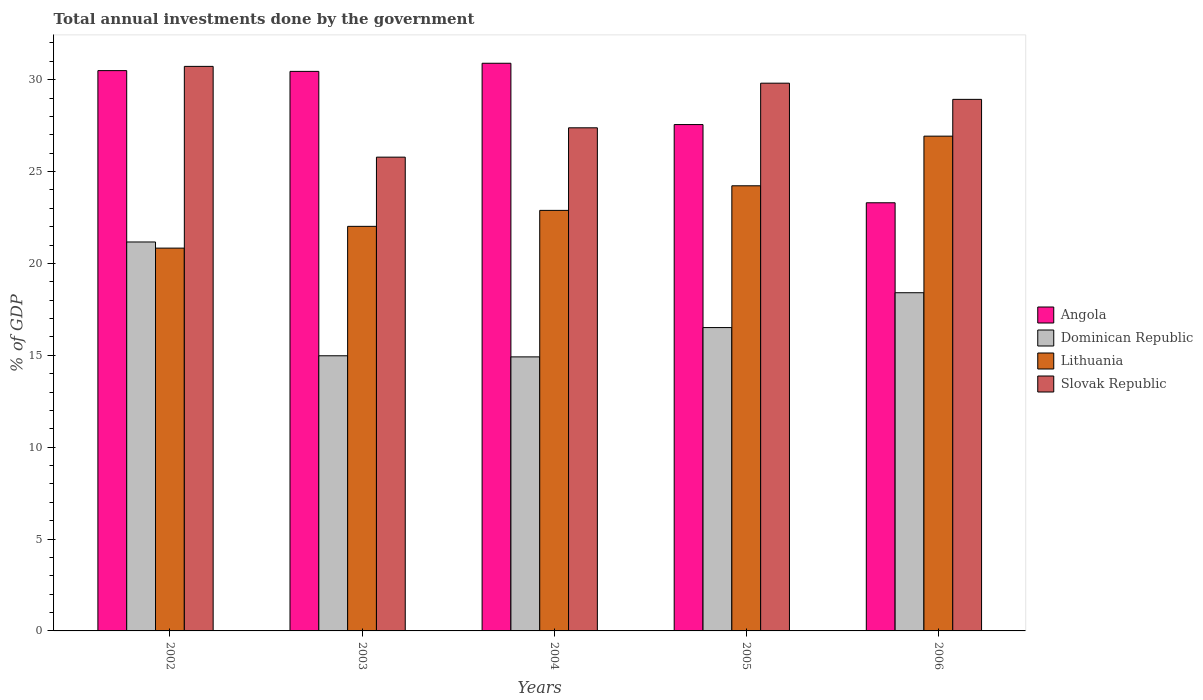How many groups of bars are there?
Give a very brief answer. 5. Are the number of bars on each tick of the X-axis equal?
Provide a succinct answer. Yes. In how many cases, is the number of bars for a given year not equal to the number of legend labels?
Offer a terse response. 0. What is the total annual investments done by the government in Lithuania in 2005?
Keep it short and to the point. 24.22. Across all years, what is the maximum total annual investments done by the government in Dominican Republic?
Keep it short and to the point. 21.17. Across all years, what is the minimum total annual investments done by the government in Dominican Republic?
Give a very brief answer. 14.91. In which year was the total annual investments done by the government in Dominican Republic maximum?
Provide a succinct answer. 2002. In which year was the total annual investments done by the government in Angola minimum?
Your answer should be very brief. 2006. What is the total total annual investments done by the government in Slovak Republic in the graph?
Offer a terse response. 142.63. What is the difference between the total annual investments done by the government in Lithuania in 2002 and that in 2003?
Keep it short and to the point. -1.19. What is the difference between the total annual investments done by the government in Dominican Republic in 2006 and the total annual investments done by the government in Angola in 2004?
Offer a very short reply. -12.49. What is the average total annual investments done by the government in Angola per year?
Your answer should be compact. 28.54. In the year 2002, what is the difference between the total annual investments done by the government in Dominican Republic and total annual investments done by the government in Angola?
Ensure brevity in your answer.  -9.33. In how many years, is the total annual investments done by the government in Angola greater than 23 %?
Your answer should be very brief. 5. What is the ratio of the total annual investments done by the government in Slovak Republic in 2002 to that in 2004?
Your answer should be compact. 1.12. Is the total annual investments done by the government in Slovak Republic in 2004 less than that in 2006?
Keep it short and to the point. Yes. What is the difference between the highest and the second highest total annual investments done by the government in Angola?
Your answer should be compact. 0.4. What is the difference between the highest and the lowest total annual investments done by the government in Dominican Republic?
Provide a succinct answer. 6.25. In how many years, is the total annual investments done by the government in Lithuania greater than the average total annual investments done by the government in Lithuania taken over all years?
Provide a short and direct response. 2. Is the sum of the total annual investments done by the government in Dominican Republic in 2003 and 2005 greater than the maximum total annual investments done by the government in Lithuania across all years?
Your answer should be very brief. Yes. Is it the case that in every year, the sum of the total annual investments done by the government in Angola and total annual investments done by the government in Slovak Republic is greater than the sum of total annual investments done by the government in Lithuania and total annual investments done by the government in Dominican Republic?
Your answer should be very brief. No. What does the 1st bar from the left in 2005 represents?
Give a very brief answer. Angola. What does the 2nd bar from the right in 2003 represents?
Ensure brevity in your answer.  Lithuania. Is it the case that in every year, the sum of the total annual investments done by the government in Dominican Republic and total annual investments done by the government in Angola is greater than the total annual investments done by the government in Slovak Republic?
Give a very brief answer. Yes. How many bars are there?
Provide a succinct answer. 20. Where does the legend appear in the graph?
Your answer should be compact. Center right. What is the title of the graph?
Your answer should be compact. Total annual investments done by the government. What is the label or title of the X-axis?
Offer a very short reply. Years. What is the label or title of the Y-axis?
Offer a very short reply. % of GDP. What is the % of GDP of Angola in 2002?
Provide a short and direct response. 30.49. What is the % of GDP of Dominican Republic in 2002?
Offer a very short reply. 21.17. What is the % of GDP of Lithuania in 2002?
Give a very brief answer. 20.83. What is the % of GDP in Slovak Republic in 2002?
Keep it short and to the point. 30.72. What is the % of GDP of Angola in 2003?
Your response must be concise. 30.45. What is the % of GDP in Dominican Republic in 2003?
Offer a terse response. 14.97. What is the % of GDP in Lithuania in 2003?
Ensure brevity in your answer.  22.02. What is the % of GDP of Slovak Republic in 2003?
Make the answer very short. 25.78. What is the % of GDP in Angola in 2004?
Offer a very short reply. 30.89. What is the % of GDP in Dominican Republic in 2004?
Your answer should be compact. 14.91. What is the % of GDP in Lithuania in 2004?
Offer a terse response. 22.89. What is the % of GDP of Slovak Republic in 2004?
Your answer should be very brief. 27.38. What is the % of GDP of Angola in 2005?
Give a very brief answer. 27.56. What is the % of GDP of Dominican Republic in 2005?
Provide a short and direct response. 16.51. What is the % of GDP of Lithuania in 2005?
Your answer should be compact. 24.22. What is the % of GDP of Slovak Republic in 2005?
Provide a succinct answer. 29.81. What is the % of GDP in Angola in 2006?
Provide a succinct answer. 23.3. What is the % of GDP in Dominican Republic in 2006?
Your answer should be very brief. 18.41. What is the % of GDP of Lithuania in 2006?
Offer a terse response. 26.93. What is the % of GDP of Slovak Republic in 2006?
Keep it short and to the point. 28.93. Across all years, what is the maximum % of GDP in Angola?
Your answer should be compact. 30.89. Across all years, what is the maximum % of GDP in Dominican Republic?
Provide a short and direct response. 21.17. Across all years, what is the maximum % of GDP in Lithuania?
Your answer should be very brief. 26.93. Across all years, what is the maximum % of GDP in Slovak Republic?
Offer a terse response. 30.72. Across all years, what is the minimum % of GDP in Angola?
Offer a terse response. 23.3. Across all years, what is the minimum % of GDP of Dominican Republic?
Keep it short and to the point. 14.91. Across all years, what is the minimum % of GDP of Lithuania?
Ensure brevity in your answer.  20.83. Across all years, what is the minimum % of GDP in Slovak Republic?
Ensure brevity in your answer.  25.78. What is the total % of GDP of Angola in the graph?
Provide a short and direct response. 142.7. What is the total % of GDP of Dominican Republic in the graph?
Keep it short and to the point. 85.97. What is the total % of GDP in Lithuania in the graph?
Make the answer very short. 116.89. What is the total % of GDP of Slovak Republic in the graph?
Give a very brief answer. 142.63. What is the difference between the % of GDP of Angola in 2002 and that in 2003?
Offer a very short reply. 0.04. What is the difference between the % of GDP of Dominican Republic in 2002 and that in 2003?
Give a very brief answer. 6.19. What is the difference between the % of GDP in Lithuania in 2002 and that in 2003?
Offer a very short reply. -1.19. What is the difference between the % of GDP in Slovak Republic in 2002 and that in 2003?
Offer a very short reply. 4.94. What is the difference between the % of GDP in Angola in 2002 and that in 2004?
Make the answer very short. -0.4. What is the difference between the % of GDP of Dominican Republic in 2002 and that in 2004?
Offer a very short reply. 6.25. What is the difference between the % of GDP in Lithuania in 2002 and that in 2004?
Your response must be concise. -2.05. What is the difference between the % of GDP of Slovak Republic in 2002 and that in 2004?
Keep it short and to the point. 3.34. What is the difference between the % of GDP of Angola in 2002 and that in 2005?
Offer a terse response. 2.94. What is the difference between the % of GDP in Dominican Republic in 2002 and that in 2005?
Provide a short and direct response. 4.66. What is the difference between the % of GDP in Lithuania in 2002 and that in 2005?
Give a very brief answer. -3.39. What is the difference between the % of GDP of Slovak Republic in 2002 and that in 2005?
Keep it short and to the point. 0.91. What is the difference between the % of GDP of Angola in 2002 and that in 2006?
Make the answer very short. 7.19. What is the difference between the % of GDP in Dominican Republic in 2002 and that in 2006?
Your answer should be compact. 2.76. What is the difference between the % of GDP of Lithuania in 2002 and that in 2006?
Offer a very short reply. -6.09. What is the difference between the % of GDP in Slovak Republic in 2002 and that in 2006?
Your answer should be very brief. 1.79. What is the difference between the % of GDP in Angola in 2003 and that in 2004?
Provide a short and direct response. -0.44. What is the difference between the % of GDP of Dominican Republic in 2003 and that in 2004?
Keep it short and to the point. 0.06. What is the difference between the % of GDP in Lithuania in 2003 and that in 2004?
Give a very brief answer. -0.87. What is the difference between the % of GDP in Slovak Republic in 2003 and that in 2004?
Make the answer very short. -1.6. What is the difference between the % of GDP in Angola in 2003 and that in 2005?
Provide a short and direct response. 2.89. What is the difference between the % of GDP of Dominican Republic in 2003 and that in 2005?
Make the answer very short. -1.54. What is the difference between the % of GDP in Lithuania in 2003 and that in 2005?
Your answer should be very brief. -2.21. What is the difference between the % of GDP in Slovak Republic in 2003 and that in 2005?
Provide a short and direct response. -4.03. What is the difference between the % of GDP of Angola in 2003 and that in 2006?
Your response must be concise. 7.15. What is the difference between the % of GDP in Dominican Republic in 2003 and that in 2006?
Keep it short and to the point. -3.43. What is the difference between the % of GDP in Lithuania in 2003 and that in 2006?
Make the answer very short. -4.91. What is the difference between the % of GDP in Slovak Republic in 2003 and that in 2006?
Provide a succinct answer. -3.14. What is the difference between the % of GDP of Angola in 2004 and that in 2005?
Provide a short and direct response. 3.34. What is the difference between the % of GDP in Dominican Republic in 2004 and that in 2005?
Give a very brief answer. -1.6. What is the difference between the % of GDP in Lithuania in 2004 and that in 2005?
Keep it short and to the point. -1.34. What is the difference between the % of GDP in Slovak Republic in 2004 and that in 2005?
Provide a succinct answer. -2.43. What is the difference between the % of GDP in Angola in 2004 and that in 2006?
Your answer should be compact. 7.59. What is the difference between the % of GDP of Dominican Republic in 2004 and that in 2006?
Your answer should be very brief. -3.49. What is the difference between the % of GDP in Lithuania in 2004 and that in 2006?
Keep it short and to the point. -4.04. What is the difference between the % of GDP of Slovak Republic in 2004 and that in 2006?
Provide a short and direct response. -1.55. What is the difference between the % of GDP of Angola in 2005 and that in 2006?
Keep it short and to the point. 4.26. What is the difference between the % of GDP in Dominican Republic in 2005 and that in 2006?
Offer a terse response. -1.9. What is the difference between the % of GDP in Lithuania in 2005 and that in 2006?
Your answer should be compact. -2.7. What is the difference between the % of GDP of Slovak Republic in 2005 and that in 2006?
Offer a very short reply. 0.88. What is the difference between the % of GDP of Angola in 2002 and the % of GDP of Dominican Republic in 2003?
Offer a terse response. 15.52. What is the difference between the % of GDP of Angola in 2002 and the % of GDP of Lithuania in 2003?
Keep it short and to the point. 8.47. What is the difference between the % of GDP in Angola in 2002 and the % of GDP in Slovak Republic in 2003?
Your answer should be compact. 4.71. What is the difference between the % of GDP of Dominican Republic in 2002 and the % of GDP of Lithuania in 2003?
Your response must be concise. -0.85. What is the difference between the % of GDP in Dominican Republic in 2002 and the % of GDP in Slovak Republic in 2003?
Provide a succinct answer. -4.62. What is the difference between the % of GDP in Lithuania in 2002 and the % of GDP in Slovak Republic in 2003?
Keep it short and to the point. -4.95. What is the difference between the % of GDP of Angola in 2002 and the % of GDP of Dominican Republic in 2004?
Your response must be concise. 15.58. What is the difference between the % of GDP of Angola in 2002 and the % of GDP of Lithuania in 2004?
Your answer should be compact. 7.61. What is the difference between the % of GDP in Angola in 2002 and the % of GDP in Slovak Republic in 2004?
Your response must be concise. 3.11. What is the difference between the % of GDP of Dominican Republic in 2002 and the % of GDP of Lithuania in 2004?
Give a very brief answer. -1.72. What is the difference between the % of GDP of Dominican Republic in 2002 and the % of GDP of Slovak Republic in 2004?
Ensure brevity in your answer.  -6.21. What is the difference between the % of GDP in Lithuania in 2002 and the % of GDP in Slovak Republic in 2004?
Provide a succinct answer. -6.55. What is the difference between the % of GDP of Angola in 2002 and the % of GDP of Dominican Republic in 2005?
Make the answer very short. 13.98. What is the difference between the % of GDP of Angola in 2002 and the % of GDP of Lithuania in 2005?
Your answer should be compact. 6.27. What is the difference between the % of GDP in Angola in 2002 and the % of GDP in Slovak Republic in 2005?
Give a very brief answer. 0.68. What is the difference between the % of GDP in Dominican Republic in 2002 and the % of GDP in Lithuania in 2005?
Provide a short and direct response. -3.06. What is the difference between the % of GDP of Dominican Republic in 2002 and the % of GDP of Slovak Republic in 2005?
Give a very brief answer. -8.64. What is the difference between the % of GDP of Lithuania in 2002 and the % of GDP of Slovak Republic in 2005?
Offer a terse response. -8.98. What is the difference between the % of GDP in Angola in 2002 and the % of GDP in Dominican Republic in 2006?
Offer a very short reply. 12.09. What is the difference between the % of GDP in Angola in 2002 and the % of GDP in Lithuania in 2006?
Your response must be concise. 3.57. What is the difference between the % of GDP in Angola in 2002 and the % of GDP in Slovak Republic in 2006?
Ensure brevity in your answer.  1.56. What is the difference between the % of GDP in Dominican Republic in 2002 and the % of GDP in Lithuania in 2006?
Ensure brevity in your answer.  -5.76. What is the difference between the % of GDP of Dominican Republic in 2002 and the % of GDP of Slovak Republic in 2006?
Make the answer very short. -7.76. What is the difference between the % of GDP of Lithuania in 2002 and the % of GDP of Slovak Republic in 2006?
Ensure brevity in your answer.  -8.1. What is the difference between the % of GDP in Angola in 2003 and the % of GDP in Dominican Republic in 2004?
Offer a very short reply. 15.54. What is the difference between the % of GDP of Angola in 2003 and the % of GDP of Lithuania in 2004?
Keep it short and to the point. 7.56. What is the difference between the % of GDP in Angola in 2003 and the % of GDP in Slovak Republic in 2004?
Keep it short and to the point. 3.07. What is the difference between the % of GDP of Dominican Republic in 2003 and the % of GDP of Lithuania in 2004?
Ensure brevity in your answer.  -7.91. What is the difference between the % of GDP of Dominican Republic in 2003 and the % of GDP of Slovak Republic in 2004?
Keep it short and to the point. -12.41. What is the difference between the % of GDP in Lithuania in 2003 and the % of GDP in Slovak Republic in 2004?
Provide a succinct answer. -5.36. What is the difference between the % of GDP in Angola in 2003 and the % of GDP in Dominican Republic in 2005?
Keep it short and to the point. 13.94. What is the difference between the % of GDP in Angola in 2003 and the % of GDP in Lithuania in 2005?
Offer a very short reply. 6.23. What is the difference between the % of GDP of Angola in 2003 and the % of GDP of Slovak Republic in 2005?
Offer a terse response. 0.64. What is the difference between the % of GDP in Dominican Republic in 2003 and the % of GDP in Lithuania in 2005?
Provide a succinct answer. -9.25. What is the difference between the % of GDP in Dominican Republic in 2003 and the % of GDP in Slovak Republic in 2005?
Provide a short and direct response. -14.84. What is the difference between the % of GDP in Lithuania in 2003 and the % of GDP in Slovak Republic in 2005?
Offer a terse response. -7.79. What is the difference between the % of GDP in Angola in 2003 and the % of GDP in Dominican Republic in 2006?
Provide a succinct answer. 12.05. What is the difference between the % of GDP of Angola in 2003 and the % of GDP of Lithuania in 2006?
Provide a short and direct response. 3.52. What is the difference between the % of GDP of Angola in 2003 and the % of GDP of Slovak Republic in 2006?
Ensure brevity in your answer.  1.52. What is the difference between the % of GDP of Dominican Republic in 2003 and the % of GDP of Lithuania in 2006?
Your response must be concise. -11.95. What is the difference between the % of GDP in Dominican Republic in 2003 and the % of GDP in Slovak Republic in 2006?
Offer a very short reply. -13.95. What is the difference between the % of GDP in Lithuania in 2003 and the % of GDP in Slovak Republic in 2006?
Your answer should be very brief. -6.91. What is the difference between the % of GDP in Angola in 2004 and the % of GDP in Dominican Republic in 2005?
Your response must be concise. 14.38. What is the difference between the % of GDP in Angola in 2004 and the % of GDP in Lithuania in 2005?
Ensure brevity in your answer.  6.67. What is the difference between the % of GDP in Angola in 2004 and the % of GDP in Slovak Republic in 2005?
Provide a succinct answer. 1.08. What is the difference between the % of GDP in Dominican Republic in 2004 and the % of GDP in Lithuania in 2005?
Offer a very short reply. -9.31. What is the difference between the % of GDP in Dominican Republic in 2004 and the % of GDP in Slovak Republic in 2005?
Offer a terse response. -14.9. What is the difference between the % of GDP of Lithuania in 2004 and the % of GDP of Slovak Republic in 2005?
Provide a short and direct response. -6.92. What is the difference between the % of GDP of Angola in 2004 and the % of GDP of Dominican Republic in 2006?
Your response must be concise. 12.49. What is the difference between the % of GDP of Angola in 2004 and the % of GDP of Lithuania in 2006?
Make the answer very short. 3.97. What is the difference between the % of GDP of Angola in 2004 and the % of GDP of Slovak Republic in 2006?
Provide a short and direct response. 1.96. What is the difference between the % of GDP in Dominican Republic in 2004 and the % of GDP in Lithuania in 2006?
Offer a very short reply. -12.01. What is the difference between the % of GDP of Dominican Republic in 2004 and the % of GDP of Slovak Republic in 2006?
Make the answer very short. -14.02. What is the difference between the % of GDP in Lithuania in 2004 and the % of GDP in Slovak Republic in 2006?
Your answer should be very brief. -6.04. What is the difference between the % of GDP in Angola in 2005 and the % of GDP in Dominican Republic in 2006?
Give a very brief answer. 9.15. What is the difference between the % of GDP in Angola in 2005 and the % of GDP in Lithuania in 2006?
Make the answer very short. 0.63. What is the difference between the % of GDP in Angola in 2005 and the % of GDP in Slovak Republic in 2006?
Give a very brief answer. -1.37. What is the difference between the % of GDP of Dominican Republic in 2005 and the % of GDP of Lithuania in 2006?
Give a very brief answer. -10.42. What is the difference between the % of GDP in Dominican Republic in 2005 and the % of GDP in Slovak Republic in 2006?
Offer a very short reply. -12.42. What is the difference between the % of GDP in Lithuania in 2005 and the % of GDP in Slovak Republic in 2006?
Offer a very short reply. -4.7. What is the average % of GDP of Angola per year?
Provide a succinct answer. 28.54. What is the average % of GDP of Dominican Republic per year?
Give a very brief answer. 17.19. What is the average % of GDP in Lithuania per year?
Your answer should be very brief. 23.38. What is the average % of GDP of Slovak Republic per year?
Provide a succinct answer. 28.53. In the year 2002, what is the difference between the % of GDP of Angola and % of GDP of Dominican Republic?
Give a very brief answer. 9.33. In the year 2002, what is the difference between the % of GDP in Angola and % of GDP in Lithuania?
Provide a short and direct response. 9.66. In the year 2002, what is the difference between the % of GDP in Angola and % of GDP in Slovak Republic?
Provide a short and direct response. -0.23. In the year 2002, what is the difference between the % of GDP in Dominican Republic and % of GDP in Lithuania?
Keep it short and to the point. 0.33. In the year 2002, what is the difference between the % of GDP of Dominican Republic and % of GDP of Slovak Republic?
Make the answer very short. -9.56. In the year 2002, what is the difference between the % of GDP in Lithuania and % of GDP in Slovak Republic?
Offer a terse response. -9.89. In the year 2003, what is the difference between the % of GDP in Angola and % of GDP in Dominican Republic?
Give a very brief answer. 15.48. In the year 2003, what is the difference between the % of GDP of Angola and % of GDP of Lithuania?
Offer a very short reply. 8.43. In the year 2003, what is the difference between the % of GDP of Angola and % of GDP of Slovak Republic?
Your answer should be very brief. 4.67. In the year 2003, what is the difference between the % of GDP in Dominican Republic and % of GDP in Lithuania?
Your answer should be compact. -7.04. In the year 2003, what is the difference between the % of GDP of Dominican Republic and % of GDP of Slovak Republic?
Give a very brief answer. -10.81. In the year 2003, what is the difference between the % of GDP of Lithuania and % of GDP of Slovak Republic?
Ensure brevity in your answer.  -3.77. In the year 2004, what is the difference between the % of GDP of Angola and % of GDP of Dominican Republic?
Make the answer very short. 15.98. In the year 2004, what is the difference between the % of GDP in Angola and % of GDP in Lithuania?
Your answer should be very brief. 8.01. In the year 2004, what is the difference between the % of GDP in Angola and % of GDP in Slovak Republic?
Provide a succinct answer. 3.51. In the year 2004, what is the difference between the % of GDP of Dominican Republic and % of GDP of Lithuania?
Your answer should be very brief. -7.97. In the year 2004, what is the difference between the % of GDP of Dominican Republic and % of GDP of Slovak Republic?
Provide a short and direct response. -12.47. In the year 2004, what is the difference between the % of GDP of Lithuania and % of GDP of Slovak Republic?
Offer a terse response. -4.49. In the year 2005, what is the difference between the % of GDP in Angola and % of GDP in Dominican Republic?
Offer a terse response. 11.05. In the year 2005, what is the difference between the % of GDP of Angola and % of GDP of Lithuania?
Provide a short and direct response. 3.33. In the year 2005, what is the difference between the % of GDP in Angola and % of GDP in Slovak Republic?
Provide a succinct answer. -2.25. In the year 2005, what is the difference between the % of GDP in Dominican Republic and % of GDP in Lithuania?
Provide a short and direct response. -7.72. In the year 2005, what is the difference between the % of GDP of Dominican Republic and % of GDP of Slovak Republic?
Your answer should be compact. -13.3. In the year 2005, what is the difference between the % of GDP in Lithuania and % of GDP in Slovak Republic?
Ensure brevity in your answer.  -5.58. In the year 2006, what is the difference between the % of GDP of Angola and % of GDP of Dominican Republic?
Offer a very short reply. 4.9. In the year 2006, what is the difference between the % of GDP in Angola and % of GDP in Lithuania?
Provide a succinct answer. -3.63. In the year 2006, what is the difference between the % of GDP in Angola and % of GDP in Slovak Republic?
Provide a succinct answer. -5.63. In the year 2006, what is the difference between the % of GDP of Dominican Republic and % of GDP of Lithuania?
Your answer should be very brief. -8.52. In the year 2006, what is the difference between the % of GDP of Dominican Republic and % of GDP of Slovak Republic?
Provide a succinct answer. -10.52. In the year 2006, what is the difference between the % of GDP in Lithuania and % of GDP in Slovak Republic?
Your response must be concise. -2. What is the ratio of the % of GDP of Angola in 2002 to that in 2003?
Offer a terse response. 1. What is the ratio of the % of GDP of Dominican Republic in 2002 to that in 2003?
Your answer should be compact. 1.41. What is the ratio of the % of GDP of Lithuania in 2002 to that in 2003?
Make the answer very short. 0.95. What is the ratio of the % of GDP of Slovak Republic in 2002 to that in 2003?
Keep it short and to the point. 1.19. What is the ratio of the % of GDP in Angola in 2002 to that in 2004?
Your response must be concise. 0.99. What is the ratio of the % of GDP in Dominican Republic in 2002 to that in 2004?
Provide a succinct answer. 1.42. What is the ratio of the % of GDP in Lithuania in 2002 to that in 2004?
Provide a succinct answer. 0.91. What is the ratio of the % of GDP in Slovak Republic in 2002 to that in 2004?
Provide a succinct answer. 1.12. What is the ratio of the % of GDP of Angola in 2002 to that in 2005?
Offer a very short reply. 1.11. What is the ratio of the % of GDP of Dominican Republic in 2002 to that in 2005?
Keep it short and to the point. 1.28. What is the ratio of the % of GDP in Lithuania in 2002 to that in 2005?
Ensure brevity in your answer.  0.86. What is the ratio of the % of GDP of Slovak Republic in 2002 to that in 2005?
Provide a short and direct response. 1.03. What is the ratio of the % of GDP in Angola in 2002 to that in 2006?
Provide a succinct answer. 1.31. What is the ratio of the % of GDP in Dominican Republic in 2002 to that in 2006?
Offer a terse response. 1.15. What is the ratio of the % of GDP in Lithuania in 2002 to that in 2006?
Offer a very short reply. 0.77. What is the ratio of the % of GDP of Slovak Republic in 2002 to that in 2006?
Your answer should be very brief. 1.06. What is the ratio of the % of GDP of Angola in 2003 to that in 2004?
Provide a short and direct response. 0.99. What is the ratio of the % of GDP in Dominican Republic in 2003 to that in 2004?
Make the answer very short. 1. What is the ratio of the % of GDP in Lithuania in 2003 to that in 2004?
Provide a succinct answer. 0.96. What is the ratio of the % of GDP in Slovak Republic in 2003 to that in 2004?
Keep it short and to the point. 0.94. What is the ratio of the % of GDP in Angola in 2003 to that in 2005?
Your answer should be very brief. 1.1. What is the ratio of the % of GDP of Dominican Republic in 2003 to that in 2005?
Give a very brief answer. 0.91. What is the ratio of the % of GDP of Lithuania in 2003 to that in 2005?
Provide a short and direct response. 0.91. What is the ratio of the % of GDP in Slovak Republic in 2003 to that in 2005?
Provide a short and direct response. 0.86. What is the ratio of the % of GDP in Angola in 2003 to that in 2006?
Your answer should be compact. 1.31. What is the ratio of the % of GDP in Dominican Republic in 2003 to that in 2006?
Your answer should be compact. 0.81. What is the ratio of the % of GDP in Lithuania in 2003 to that in 2006?
Provide a short and direct response. 0.82. What is the ratio of the % of GDP in Slovak Republic in 2003 to that in 2006?
Your answer should be very brief. 0.89. What is the ratio of the % of GDP of Angola in 2004 to that in 2005?
Your answer should be compact. 1.12. What is the ratio of the % of GDP in Dominican Republic in 2004 to that in 2005?
Keep it short and to the point. 0.9. What is the ratio of the % of GDP of Lithuania in 2004 to that in 2005?
Make the answer very short. 0.94. What is the ratio of the % of GDP in Slovak Republic in 2004 to that in 2005?
Make the answer very short. 0.92. What is the ratio of the % of GDP of Angola in 2004 to that in 2006?
Ensure brevity in your answer.  1.33. What is the ratio of the % of GDP of Dominican Republic in 2004 to that in 2006?
Your answer should be very brief. 0.81. What is the ratio of the % of GDP in Lithuania in 2004 to that in 2006?
Keep it short and to the point. 0.85. What is the ratio of the % of GDP in Slovak Republic in 2004 to that in 2006?
Ensure brevity in your answer.  0.95. What is the ratio of the % of GDP of Angola in 2005 to that in 2006?
Your answer should be very brief. 1.18. What is the ratio of the % of GDP of Dominican Republic in 2005 to that in 2006?
Your answer should be very brief. 0.9. What is the ratio of the % of GDP in Lithuania in 2005 to that in 2006?
Make the answer very short. 0.9. What is the ratio of the % of GDP in Slovak Republic in 2005 to that in 2006?
Make the answer very short. 1.03. What is the difference between the highest and the second highest % of GDP in Angola?
Your response must be concise. 0.4. What is the difference between the highest and the second highest % of GDP of Dominican Republic?
Give a very brief answer. 2.76. What is the difference between the highest and the second highest % of GDP of Lithuania?
Keep it short and to the point. 2.7. What is the difference between the highest and the second highest % of GDP in Slovak Republic?
Provide a short and direct response. 0.91. What is the difference between the highest and the lowest % of GDP of Angola?
Offer a very short reply. 7.59. What is the difference between the highest and the lowest % of GDP in Dominican Republic?
Offer a very short reply. 6.25. What is the difference between the highest and the lowest % of GDP in Lithuania?
Your answer should be compact. 6.09. What is the difference between the highest and the lowest % of GDP of Slovak Republic?
Offer a terse response. 4.94. 